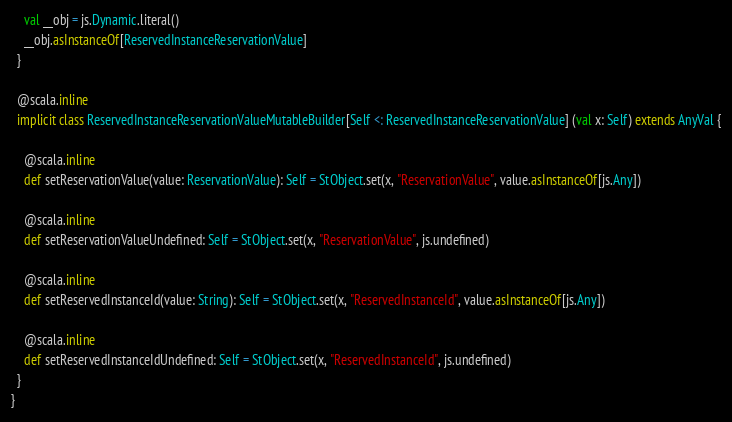<code> <loc_0><loc_0><loc_500><loc_500><_Scala_>    val __obj = js.Dynamic.literal()
    __obj.asInstanceOf[ReservedInstanceReservationValue]
  }
  
  @scala.inline
  implicit class ReservedInstanceReservationValueMutableBuilder[Self <: ReservedInstanceReservationValue] (val x: Self) extends AnyVal {
    
    @scala.inline
    def setReservationValue(value: ReservationValue): Self = StObject.set(x, "ReservationValue", value.asInstanceOf[js.Any])
    
    @scala.inline
    def setReservationValueUndefined: Self = StObject.set(x, "ReservationValue", js.undefined)
    
    @scala.inline
    def setReservedInstanceId(value: String): Self = StObject.set(x, "ReservedInstanceId", value.asInstanceOf[js.Any])
    
    @scala.inline
    def setReservedInstanceIdUndefined: Self = StObject.set(x, "ReservedInstanceId", js.undefined)
  }
}
</code> 